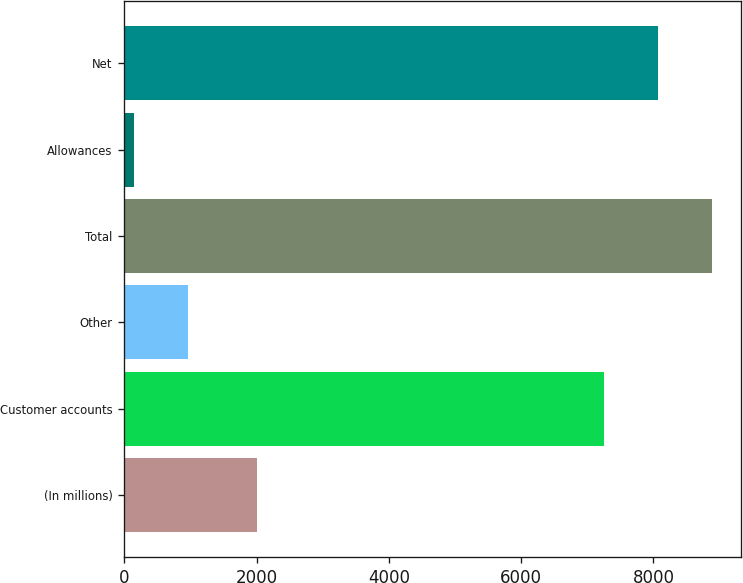Convert chart to OTSL. <chart><loc_0><loc_0><loc_500><loc_500><bar_chart><fcel>(In millions)<fcel>Customer accounts<fcel>Other<fcel>Total<fcel>Allowances<fcel>Net<nl><fcel>2010<fcel>7256<fcel>968<fcel>8882.5<fcel>149<fcel>8075<nl></chart> 